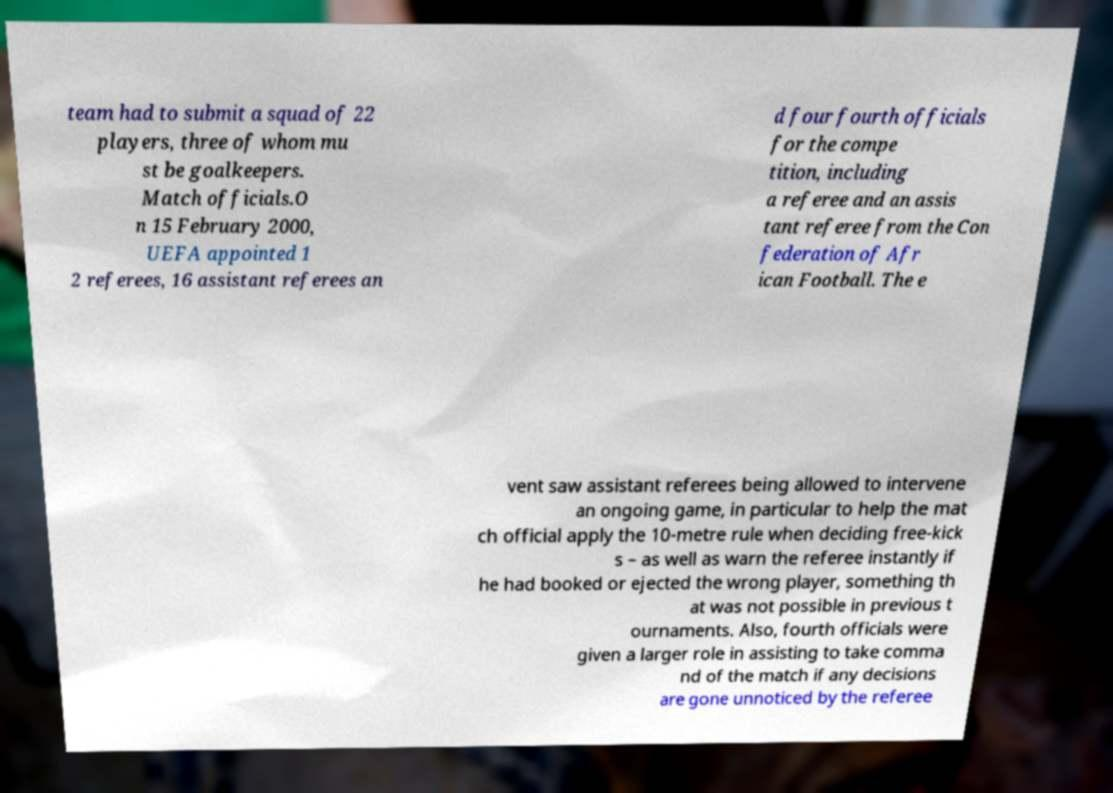There's text embedded in this image that I need extracted. Can you transcribe it verbatim? team had to submit a squad of 22 players, three of whom mu st be goalkeepers. Match officials.O n 15 February 2000, UEFA appointed 1 2 referees, 16 assistant referees an d four fourth officials for the compe tition, including a referee and an assis tant referee from the Con federation of Afr ican Football. The e vent saw assistant referees being allowed to intervene an ongoing game, in particular to help the mat ch official apply the 10-metre rule when deciding free-kick s – as well as warn the referee instantly if he had booked or ejected the wrong player, something th at was not possible in previous t ournaments. Also, fourth officials were given a larger role in assisting to take comma nd of the match if any decisions are gone unnoticed by the referee 